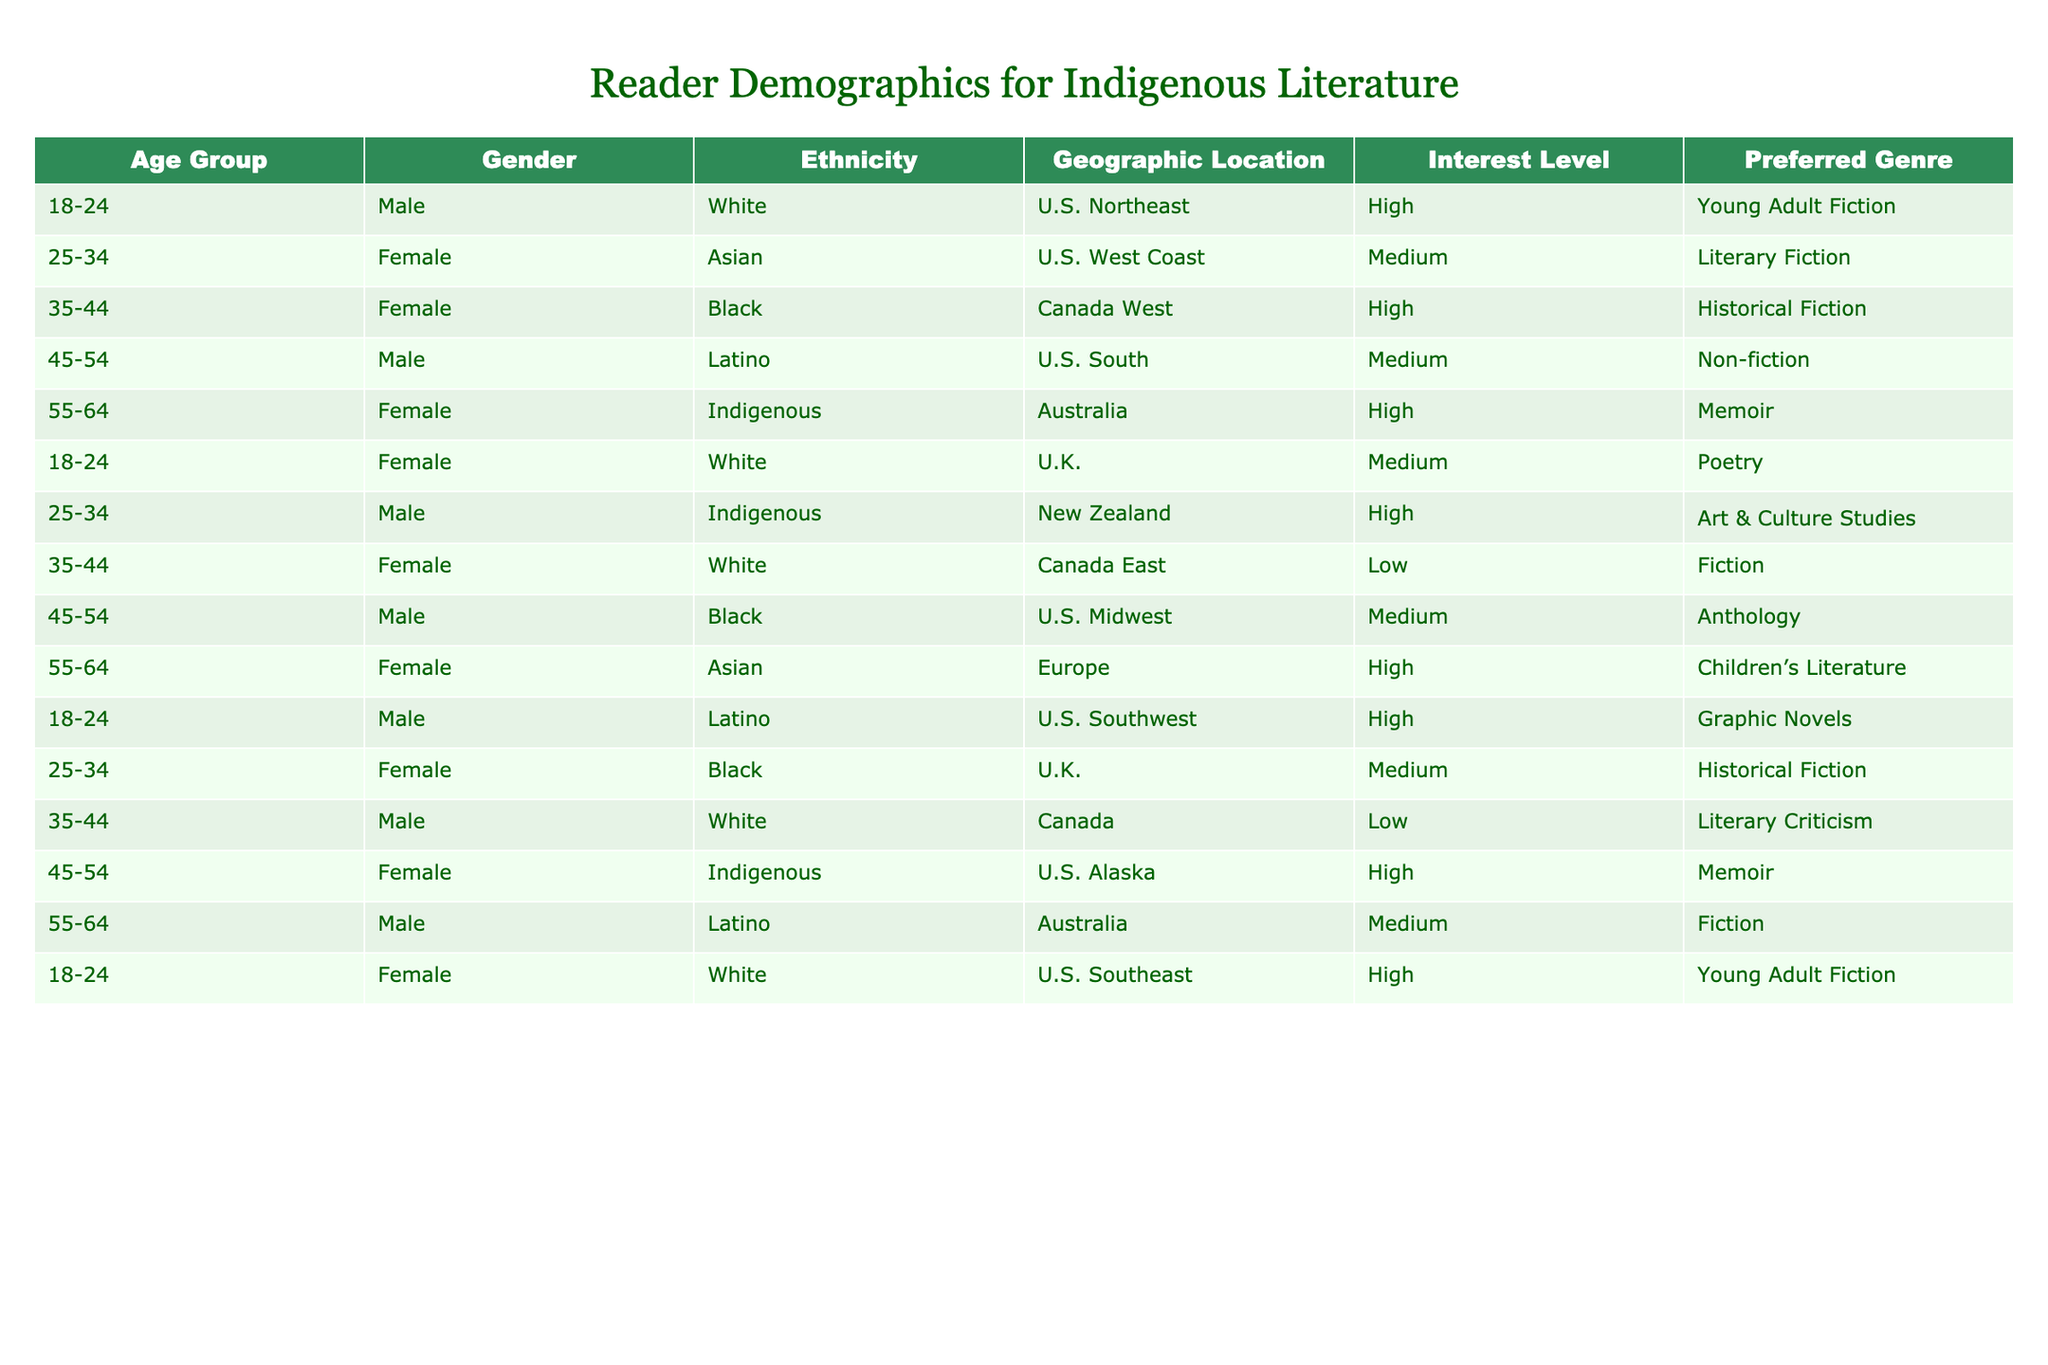What is the preferred genre of the Indigenous female reader aged 55-64 from Australia? The table has a row for a female reader aged 55-64 from Australia who identifies as Indigenous, and her preferred genre is listed as Memoir.
Answer: Memoir How many readers have a high interest level in literature focusing on Indigenous culture? From the table, we can count the readers with a high interest level which are: one female aged 55-64 from Australia, one male aged 25-34 from New Zealand, and one female aged 45-54 from U.S. Alaska. This gives a total of 3 readers with high interest level.
Answer: 3 Is there any male reader from the U.S. Southwest interested in Graphic Novels? The table shows a male reader aged 18-24 from the U.S. Southwest who has a high interest level in Graphic Novels. Thus, the statement is true.
Answer: Yes What is the average age of female readers interested in Memoir? Two female readers were identified as interested in Memoir: one aged 55-64 from Australia and another aged 45-54 from U.S. Alaska. To find the average age, add 55 and 45, resulting in 100, then divide by 2, which equals 50 years.
Answer: 50 What percentage of readers identified as Indigenous have a high interest level? There are three Indigenous readers: one female aged 55-64 from Australia with high interest, one male aged 25-34 from New Zealand also with high interest, and one female aged 45-54 from U.S. Alaska with high interest. Since all three have high interest, divide 3 (high interest readers) by 3 (total Indigenous readers) to get 100%.
Answer: 100% What genre is preferred by the highest number of female readers? By reviewing the table, we can see that several female readers are listed with their respective genres. Historical Fiction appears two times (ages 34-44 and 25-34), while Memoir and Young Adult Fiction also appear twice, but so does Asian representation in Children's Literature. Since Memoir appears for Indigenous readers, if we tally them, we find Historical Fiction appears most frequently among female readers.
Answer: Historical Fiction 